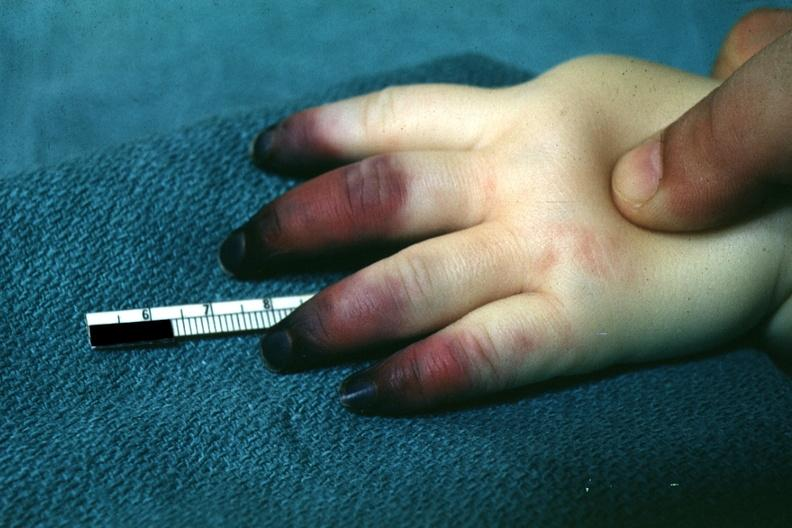what does this image show?
Answer the question using a single word or phrase. Outstandingly horrible example in infant with apparent gangrene of distal and middle phalanges pseudomonas sepsis 